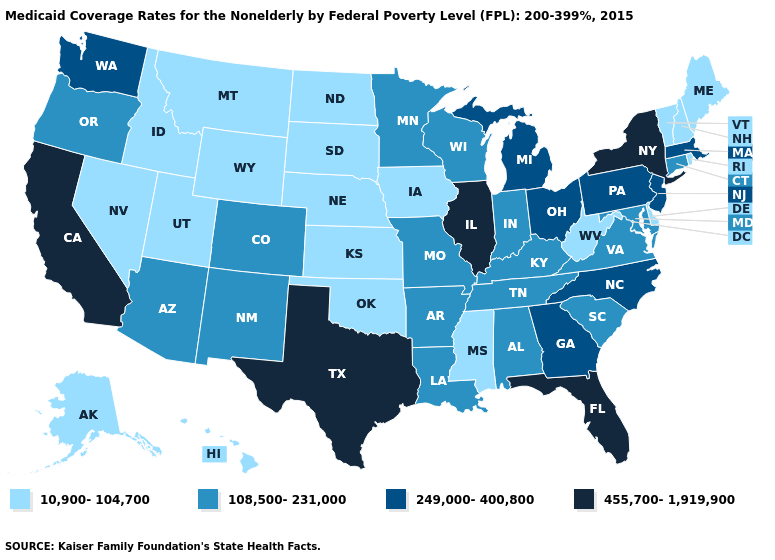What is the highest value in the USA?
Quick response, please. 455,700-1,919,900. Name the states that have a value in the range 10,900-104,700?
Answer briefly. Alaska, Delaware, Hawaii, Idaho, Iowa, Kansas, Maine, Mississippi, Montana, Nebraska, Nevada, New Hampshire, North Dakota, Oklahoma, Rhode Island, South Dakota, Utah, Vermont, West Virginia, Wyoming. Which states hav the highest value in the West?
Be succinct. California. Among the states that border Wyoming , does Idaho have the lowest value?
Give a very brief answer. Yes. Does New York have the highest value in the USA?
Give a very brief answer. Yes. Does Arkansas have the lowest value in the USA?
Keep it brief. No. What is the value of Michigan?
Write a very short answer. 249,000-400,800. Name the states that have a value in the range 10,900-104,700?
Be succinct. Alaska, Delaware, Hawaii, Idaho, Iowa, Kansas, Maine, Mississippi, Montana, Nebraska, Nevada, New Hampshire, North Dakota, Oklahoma, Rhode Island, South Dakota, Utah, Vermont, West Virginia, Wyoming. What is the highest value in the South ?
Concise answer only. 455,700-1,919,900. Name the states that have a value in the range 249,000-400,800?
Answer briefly. Georgia, Massachusetts, Michigan, New Jersey, North Carolina, Ohio, Pennsylvania, Washington. Among the states that border Georgia , does Alabama have the lowest value?
Be succinct. Yes. Does the map have missing data?
Write a very short answer. No. Name the states that have a value in the range 108,500-231,000?
Be succinct. Alabama, Arizona, Arkansas, Colorado, Connecticut, Indiana, Kentucky, Louisiana, Maryland, Minnesota, Missouri, New Mexico, Oregon, South Carolina, Tennessee, Virginia, Wisconsin. What is the value of North Dakota?
Give a very brief answer. 10,900-104,700. What is the lowest value in the USA?
Write a very short answer. 10,900-104,700. 